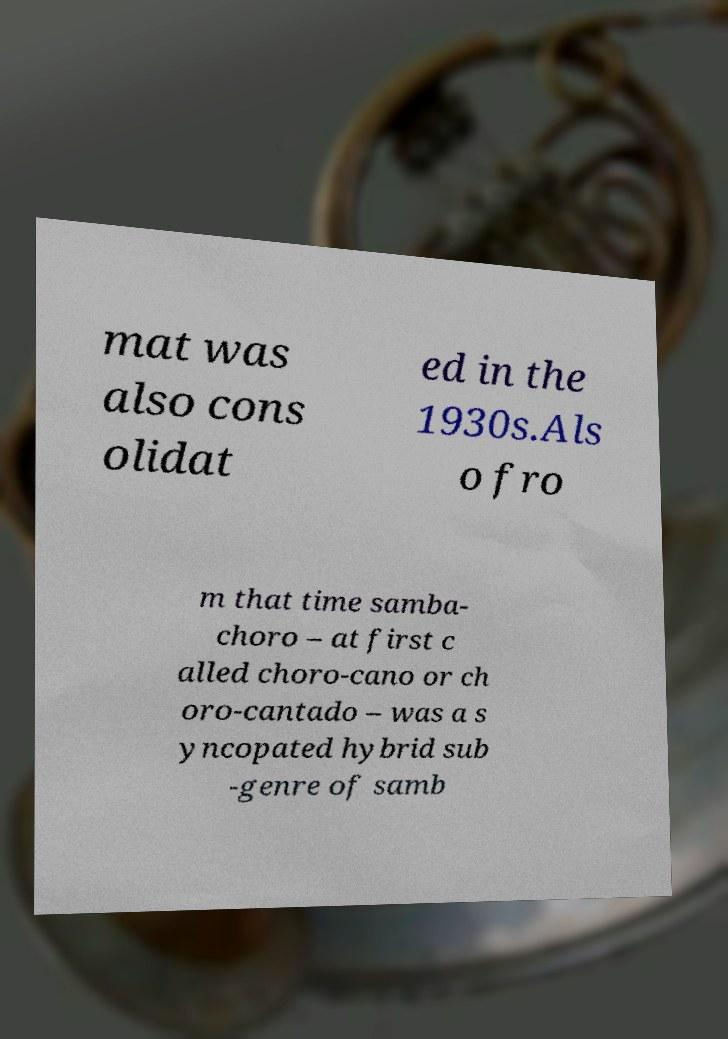There's text embedded in this image that I need extracted. Can you transcribe it verbatim? mat was also cons olidat ed in the 1930s.Als o fro m that time samba- choro – at first c alled choro-cano or ch oro-cantado – was a s yncopated hybrid sub -genre of samb 